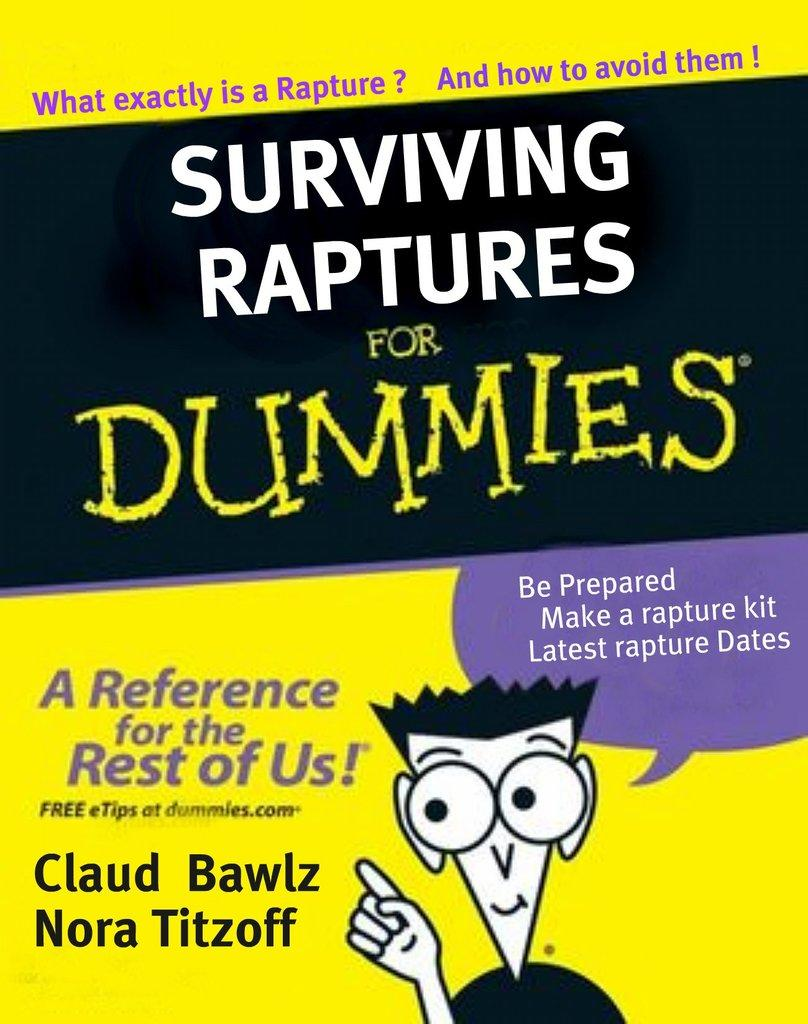<image>
Render a clear and concise summary of the photo. A yellow book titled Surviving Raptures for Dummies 